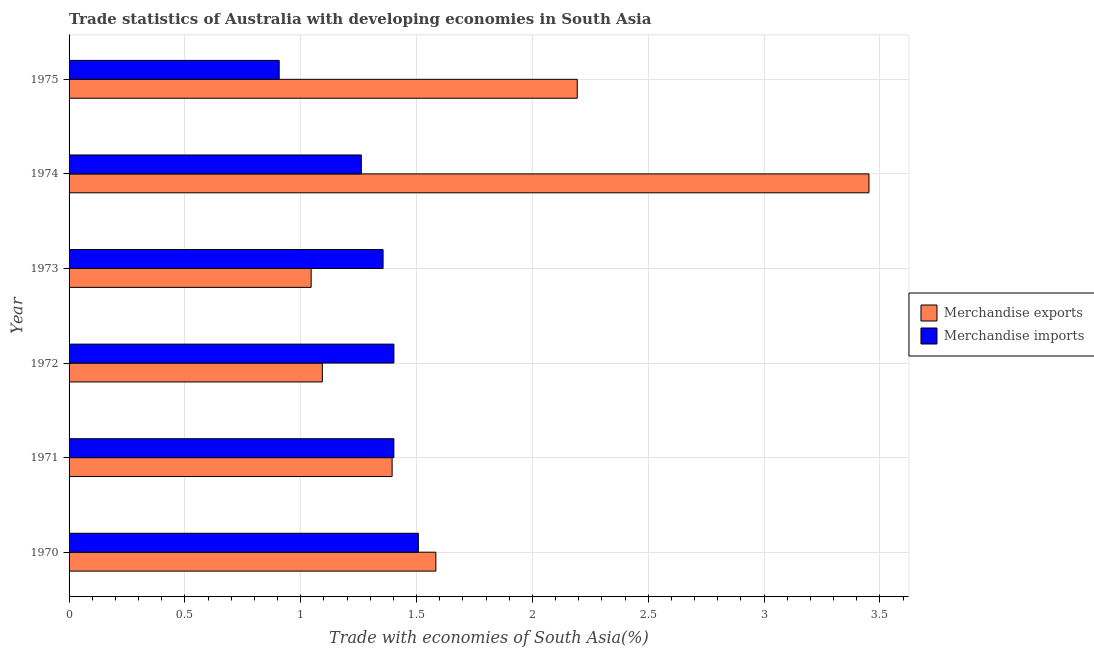How many different coloured bars are there?
Your response must be concise. 2. Are the number of bars per tick equal to the number of legend labels?
Make the answer very short. Yes. How many bars are there on the 3rd tick from the top?
Ensure brevity in your answer.  2. What is the merchandise imports in 1974?
Give a very brief answer. 1.26. Across all years, what is the maximum merchandise imports?
Provide a succinct answer. 1.51. Across all years, what is the minimum merchandise imports?
Provide a short and direct response. 0.91. In which year was the merchandise imports maximum?
Your response must be concise. 1970. What is the total merchandise exports in the graph?
Provide a short and direct response. 10.76. What is the difference between the merchandise exports in 1973 and that in 1975?
Your answer should be compact. -1.15. What is the difference between the merchandise exports in 1975 and the merchandise imports in 1973?
Ensure brevity in your answer.  0.84. What is the average merchandise exports per year?
Keep it short and to the point. 1.79. In the year 1971, what is the difference between the merchandise exports and merchandise imports?
Provide a short and direct response. -0.01. What is the ratio of the merchandise exports in 1974 to that in 1975?
Your answer should be compact. 1.57. Is the merchandise imports in 1971 less than that in 1974?
Provide a short and direct response. No. What is the difference between the highest and the second highest merchandise imports?
Keep it short and to the point. 0.11. In how many years, is the merchandise imports greater than the average merchandise imports taken over all years?
Ensure brevity in your answer.  4. Is the sum of the merchandise imports in 1970 and 1972 greater than the maximum merchandise exports across all years?
Offer a very short reply. No. What does the 1st bar from the top in 1972 represents?
Make the answer very short. Merchandise imports. Are all the bars in the graph horizontal?
Provide a succinct answer. Yes. How many years are there in the graph?
Your answer should be very brief. 6. What is the difference between two consecutive major ticks on the X-axis?
Your response must be concise. 0.5. Does the graph contain any zero values?
Give a very brief answer. No. Does the graph contain grids?
Keep it short and to the point. Yes. Where does the legend appear in the graph?
Provide a succinct answer. Center right. How many legend labels are there?
Your answer should be compact. 2. How are the legend labels stacked?
Provide a succinct answer. Vertical. What is the title of the graph?
Your response must be concise. Trade statistics of Australia with developing economies in South Asia. Does "Arms imports" appear as one of the legend labels in the graph?
Keep it short and to the point. No. What is the label or title of the X-axis?
Offer a terse response. Trade with economies of South Asia(%). What is the Trade with economies of South Asia(%) in Merchandise exports in 1970?
Ensure brevity in your answer.  1.58. What is the Trade with economies of South Asia(%) of Merchandise imports in 1970?
Your answer should be compact. 1.51. What is the Trade with economies of South Asia(%) in Merchandise exports in 1971?
Your response must be concise. 1.39. What is the Trade with economies of South Asia(%) of Merchandise imports in 1971?
Give a very brief answer. 1.4. What is the Trade with economies of South Asia(%) in Merchandise exports in 1972?
Provide a short and direct response. 1.09. What is the Trade with economies of South Asia(%) of Merchandise imports in 1972?
Your answer should be very brief. 1.4. What is the Trade with economies of South Asia(%) of Merchandise exports in 1973?
Offer a terse response. 1.04. What is the Trade with economies of South Asia(%) of Merchandise imports in 1973?
Give a very brief answer. 1.36. What is the Trade with economies of South Asia(%) of Merchandise exports in 1974?
Ensure brevity in your answer.  3.45. What is the Trade with economies of South Asia(%) in Merchandise imports in 1974?
Your response must be concise. 1.26. What is the Trade with economies of South Asia(%) of Merchandise exports in 1975?
Your answer should be very brief. 2.19. What is the Trade with economies of South Asia(%) of Merchandise imports in 1975?
Provide a short and direct response. 0.91. Across all years, what is the maximum Trade with economies of South Asia(%) in Merchandise exports?
Keep it short and to the point. 3.45. Across all years, what is the maximum Trade with economies of South Asia(%) of Merchandise imports?
Your answer should be compact. 1.51. Across all years, what is the minimum Trade with economies of South Asia(%) in Merchandise exports?
Your response must be concise. 1.04. Across all years, what is the minimum Trade with economies of South Asia(%) in Merchandise imports?
Your answer should be compact. 0.91. What is the total Trade with economies of South Asia(%) in Merchandise exports in the graph?
Give a very brief answer. 10.76. What is the total Trade with economies of South Asia(%) in Merchandise imports in the graph?
Make the answer very short. 7.84. What is the difference between the Trade with economies of South Asia(%) in Merchandise exports in 1970 and that in 1971?
Make the answer very short. 0.19. What is the difference between the Trade with economies of South Asia(%) in Merchandise imports in 1970 and that in 1971?
Give a very brief answer. 0.11. What is the difference between the Trade with economies of South Asia(%) of Merchandise exports in 1970 and that in 1972?
Offer a terse response. 0.49. What is the difference between the Trade with economies of South Asia(%) in Merchandise imports in 1970 and that in 1972?
Offer a very short reply. 0.11. What is the difference between the Trade with economies of South Asia(%) of Merchandise exports in 1970 and that in 1973?
Your answer should be compact. 0.54. What is the difference between the Trade with economies of South Asia(%) of Merchandise imports in 1970 and that in 1973?
Offer a very short reply. 0.15. What is the difference between the Trade with economies of South Asia(%) of Merchandise exports in 1970 and that in 1974?
Your answer should be compact. -1.87. What is the difference between the Trade with economies of South Asia(%) of Merchandise imports in 1970 and that in 1974?
Offer a very short reply. 0.25. What is the difference between the Trade with economies of South Asia(%) in Merchandise exports in 1970 and that in 1975?
Provide a succinct answer. -0.61. What is the difference between the Trade with economies of South Asia(%) in Merchandise imports in 1970 and that in 1975?
Your answer should be compact. 0.6. What is the difference between the Trade with economies of South Asia(%) of Merchandise exports in 1971 and that in 1972?
Your answer should be compact. 0.3. What is the difference between the Trade with economies of South Asia(%) in Merchandise imports in 1971 and that in 1972?
Your answer should be very brief. -0. What is the difference between the Trade with economies of South Asia(%) of Merchandise exports in 1971 and that in 1973?
Your answer should be very brief. 0.35. What is the difference between the Trade with economies of South Asia(%) of Merchandise imports in 1971 and that in 1973?
Your answer should be very brief. 0.05. What is the difference between the Trade with economies of South Asia(%) in Merchandise exports in 1971 and that in 1974?
Your answer should be very brief. -2.06. What is the difference between the Trade with economies of South Asia(%) in Merchandise imports in 1971 and that in 1974?
Offer a terse response. 0.14. What is the difference between the Trade with economies of South Asia(%) of Merchandise exports in 1971 and that in 1975?
Your response must be concise. -0.8. What is the difference between the Trade with economies of South Asia(%) of Merchandise imports in 1971 and that in 1975?
Your answer should be compact. 0.49. What is the difference between the Trade with economies of South Asia(%) of Merchandise exports in 1972 and that in 1973?
Your response must be concise. 0.05. What is the difference between the Trade with economies of South Asia(%) in Merchandise imports in 1972 and that in 1973?
Make the answer very short. 0.05. What is the difference between the Trade with economies of South Asia(%) of Merchandise exports in 1972 and that in 1974?
Your answer should be very brief. -2.36. What is the difference between the Trade with economies of South Asia(%) in Merchandise imports in 1972 and that in 1974?
Offer a terse response. 0.14. What is the difference between the Trade with economies of South Asia(%) in Merchandise exports in 1972 and that in 1975?
Your answer should be compact. -1.1. What is the difference between the Trade with economies of South Asia(%) of Merchandise imports in 1972 and that in 1975?
Offer a terse response. 0.5. What is the difference between the Trade with economies of South Asia(%) in Merchandise exports in 1973 and that in 1974?
Provide a succinct answer. -2.41. What is the difference between the Trade with economies of South Asia(%) of Merchandise imports in 1973 and that in 1974?
Your answer should be compact. 0.09. What is the difference between the Trade with economies of South Asia(%) of Merchandise exports in 1973 and that in 1975?
Make the answer very short. -1.15. What is the difference between the Trade with economies of South Asia(%) of Merchandise imports in 1973 and that in 1975?
Make the answer very short. 0.45. What is the difference between the Trade with economies of South Asia(%) in Merchandise exports in 1974 and that in 1975?
Give a very brief answer. 1.26. What is the difference between the Trade with economies of South Asia(%) in Merchandise imports in 1974 and that in 1975?
Provide a short and direct response. 0.35. What is the difference between the Trade with economies of South Asia(%) in Merchandise exports in 1970 and the Trade with economies of South Asia(%) in Merchandise imports in 1971?
Give a very brief answer. 0.18. What is the difference between the Trade with economies of South Asia(%) in Merchandise exports in 1970 and the Trade with economies of South Asia(%) in Merchandise imports in 1972?
Make the answer very short. 0.18. What is the difference between the Trade with economies of South Asia(%) of Merchandise exports in 1970 and the Trade with economies of South Asia(%) of Merchandise imports in 1973?
Your answer should be very brief. 0.23. What is the difference between the Trade with economies of South Asia(%) of Merchandise exports in 1970 and the Trade with economies of South Asia(%) of Merchandise imports in 1974?
Provide a succinct answer. 0.32. What is the difference between the Trade with economies of South Asia(%) in Merchandise exports in 1970 and the Trade with economies of South Asia(%) in Merchandise imports in 1975?
Give a very brief answer. 0.68. What is the difference between the Trade with economies of South Asia(%) of Merchandise exports in 1971 and the Trade with economies of South Asia(%) of Merchandise imports in 1972?
Give a very brief answer. -0.01. What is the difference between the Trade with economies of South Asia(%) of Merchandise exports in 1971 and the Trade with economies of South Asia(%) of Merchandise imports in 1973?
Your response must be concise. 0.04. What is the difference between the Trade with economies of South Asia(%) in Merchandise exports in 1971 and the Trade with economies of South Asia(%) in Merchandise imports in 1974?
Offer a terse response. 0.13. What is the difference between the Trade with economies of South Asia(%) of Merchandise exports in 1971 and the Trade with economies of South Asia(%) of Merchandise imports in 1975?
Your answer should be compact. 0.49. What is the difference between the Trade with economies of South Asia(%) of Merchandise exports in 1972 and the Trade with economies of South Asia(%) of Merchandise imports in 1973?
Offer a terse response. -0.26. What is the difference between the Trade with economies of South Asia(%) in Merchandise exports in 1972 and the Trade with economies of South Asia(%) in Merchandise imports in 1974?
Your response must be concise. -0.17. What is the difference between the Trade with economies of South Asia(%) of Merchandise exports in 1972 and the Trade with economies of South Asia(%) of Merchandise imports in 1975?
Your answer should be compact. 0.19. What is the difference between the Trade with economies of South Asia(%) of Merchandise exports in 1973 and the Trade with economies of South Asia(%) of Merchandise imports in 1974?
Your answer should be very brief. -0.22. What is the difference between the Trade with economies of South Asia(%) of Merchandise exports in 1973 and the Trade with economies of South Asia(%) of Merchandise imports in 1975?
Your answer should be very brief. 0.14. What is the difference between the Trade with economies of South Asia(%) of Merchandise exports in 1974 and the Trade with economies of South Asia(%) of Merchandise imports in 1975?
Offer a terse response. 2.55. What is the average Trade with economies of South Asia(%) in Merchandise exports per year?
Make the answer very short. 1.79. What is the average Trade with economies of South Asia(%) in Merchandise imports per year?
Your answer should be compact. 1.31. In the year 1970, what is the difference between the Trade with economies of South Asia(%) of Merchandise exports and Trade with economies of South Asia(%) of Merchandise imports?
Keep it short and to the point. 0.08. In the year 1971, what is the difference between the Trade with economies of South Asia(%) in Merchandise exports and Trade with economies of South Asia(%) in Merchandise imports?
Your answer should be very brief. -0.01. In the year 1972, what is the difference between the Trade with economies of South Asia(%) of Merchandise exports and Trade with economies of South Asia(%) of Merchandise imports?
Provide a succinct answer. -0.31. In the year 1973, what is the difference between the Trade with economies of South Asia(%) of Merchandise exports and Trade with economies of South Asia(%) of Merchandise imports?
Give a very brief answer. -0.31. In the year 1974, what is the difference between the Trade with economies of South Asia(%) in Merchandise exports and Trade with economies of South Asia(%) in Merchandise imports?
Your response must be concise. 2.19. In the year 1975, what is the difference between the Trade with economies of South Asia(%) of Merchandise exports and Trade with economies of South Asia(%) of Merchandise imports?
Ensure brevity in your answer.  1.29. What is the ratio of the Trade with economies of South Asia(%) of Merchandise exports in 1970 to that in 1971?
Provide a succinct answer. 1.14. What is the ratio of the Trade with economies of South Asia(%) in Merchandise imports in 1970 to that in 1971?
Provide a succinct answer. 1.08. What is the ratio of the Trade with economies of South Asia(%) in Merchandise exports in 1970 to that in 1972?
Offer a very short reply. 1.45. What is the ratio of the Trade with economies of South Asia(%) of Merchandise imports in 1970 to that in 1972?
Your answer should be very brief. 1.08. What is the ratio of the Trade with economies of South Asia(%) of Merchandise exports in 1970 to that in 1973?
Offer a terse response. 1.52. What is the ratio of the Trade with economies of South Asia(%) in Merchandise imports in 1970 to that in 1973?
Your response must be concise. 1.11. What is the ratio of the Trade with economies of South Asia(%) of Merchandise exports in 1970 to that in 1974?
Offer a very short reply. 0.46. What is the ratio of the Trade with economies of South Asia(%) in Merchandise imports in 1970 to that in 1974?
Give a very brief answer. 1.2. What is the ratio of the Trade with economies of South Asia(%) in Merchandise exports in 1970 to that in 1975?
Ensure brevity in your answer.  0.72. What is the ratio of the Trade with economies of South Asia(%) in Merchandise imports in 1970 to that in 1975?
Offer a very short reply. 1.66. What is the ratio of the Trade with economies of South Asia(%) in Merchandise exports in 1971 to that in 1972?
Make the answer very short. 1.28. What is the ratio of the Trade with economies of South Asia(%) of Merchandise imports in 1971 to that in 1972?
Ensure brevity in your answer.  1. What is the ratio of the Trade with economies of South Asia(%) of Merchandise exports in 1971 to that in 1973?
Offer a terse response. 1.33. What is the ratio of the Trade with economies of South Asia(%) of Merchandise imports in 1971 to that in 1973?
Your response must be concise. 1.03. What is the ratio of the Trade with economies of South Asia(%) in Merchandise exports in 1971 to that in 1974?
Offer a terse response. 0.4. What is the ratio of the Trade with economies of South Asia(%) in Merchandise imports in 1971 to that in 1974?
Give a very brief answer. 1.11. What is the ratio of the Trade with economies of South Asia(%) of Merchandise exports in 1971 to that in 1975?
Provide a short and direct response. 0.64. What is the ratio of the Trade with economies of South Asia(%) of Merchandise imports in 1971 to that in 1975?
Offer a very short reply. 1.55. What is the ratio of the Trade with economies of South Asia(%) of Merchandise exports in 1972 to that in 1973?
Your response must be concise. 1.05. What is the ratio of the Trade with economies of South Asia(%) of Merchandise imports in 1972 to that in 1973?
Give a very brief answer. 1.03. What is the ratio of the Trade with economies of South Asia(%) of Merchandise exports in 1972 to that in 1974?
Give a very brief answer. 0.32. What is the ratio of the Trade with economies of South Asia(%) of Merchandise imports in 1972 to that in 1974?
Offer a terse response. 1.11. What is the ratio of the Trade with economies of South Asia(%) of Merchandise exports in 1972 to that in 1975?
Provide a succinct answer. 0.5. What is the ratio of the Trade with economies of South Asia(%) in Merchandise imports in 1972 to that in 1975?
Offer a very short reply. 1.55. What is the ratio of the Trade with economies of South Asia(%) in Merchandise exports in 1973 to that in 1974?
Keep it short and to the point. 0.3. What is the ratio of the Trade with economies of South Asia(%) in Merchandise imports in 1973 to that in 1974?
Provide a short and direct response. 1.07. What is the ratio of the Trade with economies of South Asia(%) in Merchandise exports in 1973 to that in 1975?
Keep it short and to the point. 0.48. What is the ratio of the Trade with economies of South Asia(%) in Merchandise imports in 1973 to that in 1975?
Your answer should be very brief. 1.49. What is the ratio of the Trade with economies of South Asia(%) of Merchandise exports in 1974 to that in 1975?
Keep it short and to the point. 1.57. What is the ratio of the Trade with economies of South Asia(%) of Merchandise imports in 1974 to that in 1975?
Your answer should be compact. 1.39. What is the difference between the highest and the second highest Trade with economies of South Asia(%) in Merchandise exports?
Your response must be concise. 1.26. What is the difference between the highest and the second highest Trade with economies of South Asia(%) of Merchandise imports?
Your response must be concise. 0.11. What is the difference between the highest and the lowest Trade with economies of South Asia(%) of Merchandise exports?
Offer a terse response. 2.41. What is the difference between the highest and the lowest Trade with economies of South Asia(%) in Merchandise imports?
Make the answer very short. 0.6. 